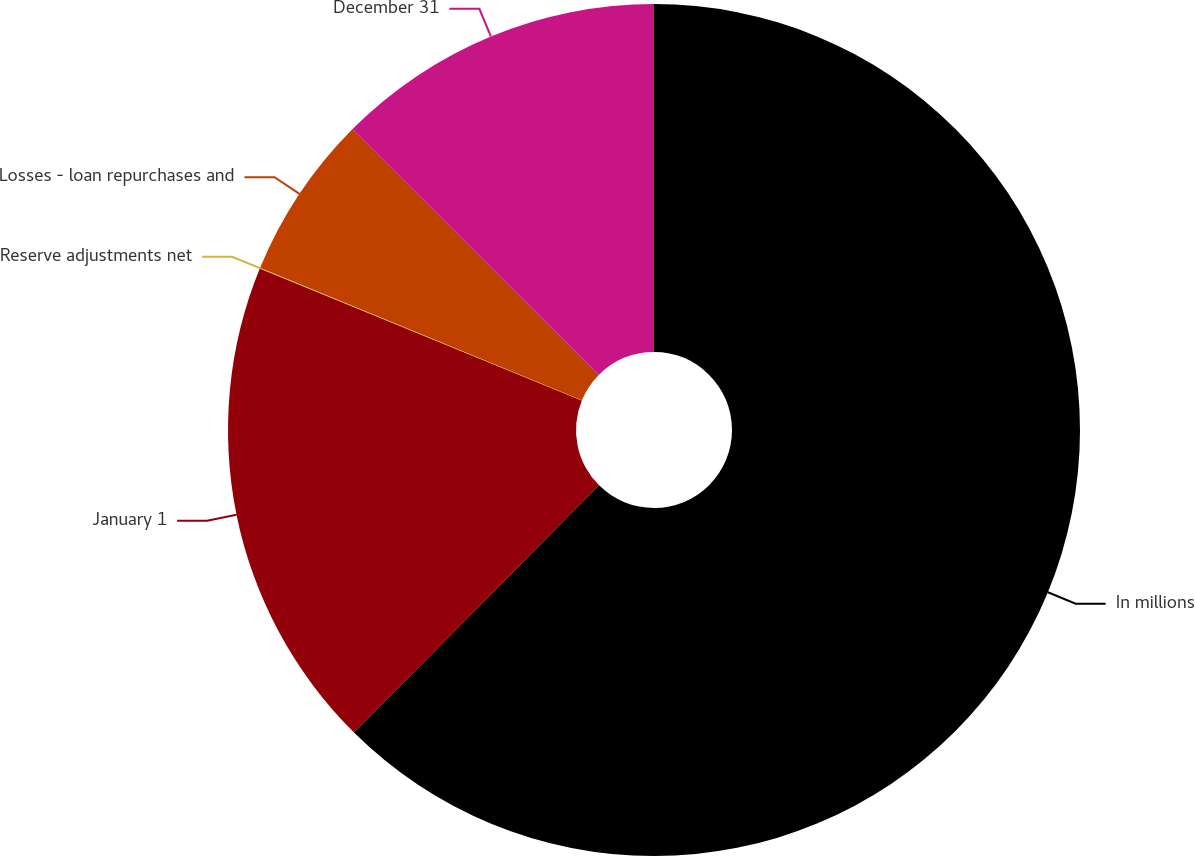<chart> <loc_0><loc_0><loc_500><loc_500><pie_chart><fcel>In millions<fcel>January 1<fcel>Reserve adjustments net<fcel>Losses - loan repurchases and<fcel>December 31<nl><fcel>62.43%<fcel>18.75%<fcel>0.03%<fcel>6.27%<fcel>12.51%<nl></chart> 